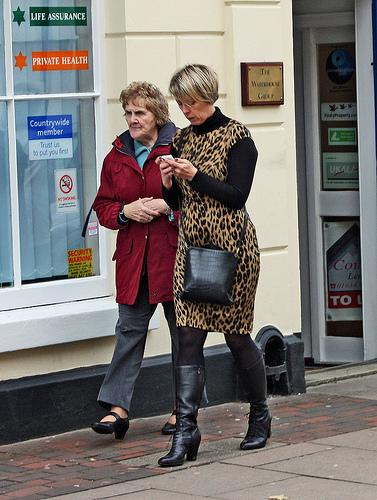For the visual entailment task, describe the conclusion that can be drawn from the relationship between the women's clothing and the signages in the image. The women are dressed in fashionable attire while walking on a sidewalk decorated with diverse and visually appealing signages, suggesting a lively and chic urban setting. Which objects in the image are used for advertisement purposes? Window stickers, a brass and wood wall plack, and business banners in the window are used as advertisement objects in the image. Identify the color and type of footwear worn by the women in the image. Both women are wearing black footwear, one with high-heeled boots, and the other with high-heeled Mary Jane shoes. What type of clothing is the first woman wearing and what is she doing? The woman is wearing an animal print dress and holding a cell phone in her hand. In the context of a multichoice VQA task, what would be the focus of the questions related to this scene? The questions would focus on identifying and analyzing specific elements like clothing, footwear, accessories, and surroundings of the women in the image. Pick one woman in the image and describe her outfit, footwear, and accessories. The woman is wearing a red and blue winter coat, black high-heeled boots, and holding a black purse and cell phone in her hand. For a product advertisement, select a single item in the image and provide a brief sales pitch. Upgrade your style with our stunning animal print dress, perfect for making an unforgettable statement while comfortably walking down the street. For the visual entailment task, describe the relationship between the women's clothing and path they are on. The women are wearing stylish clothes, such as animal print dress and red winter coat, while walking on a mixed brick walkway or sidewalk. 